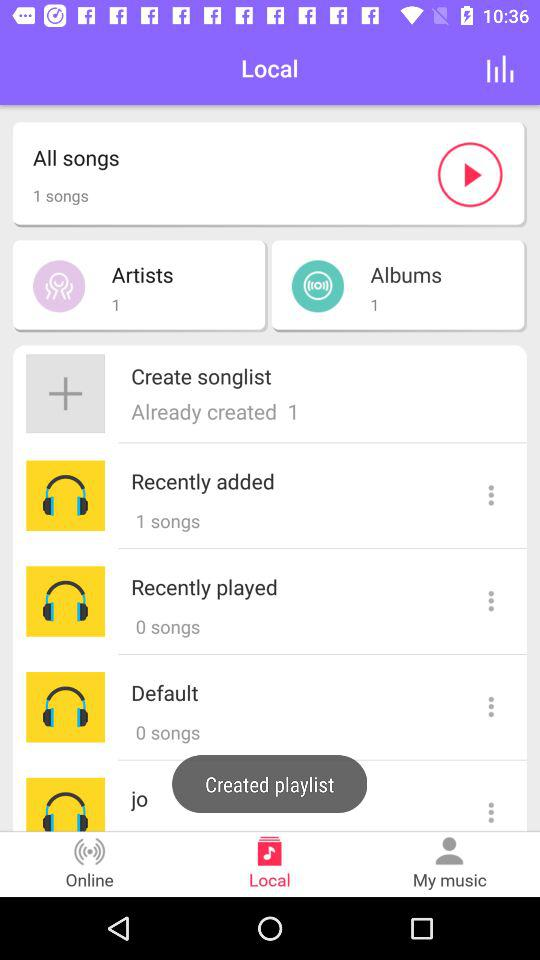How many songs are there in "All songs"? There is 1 song. 